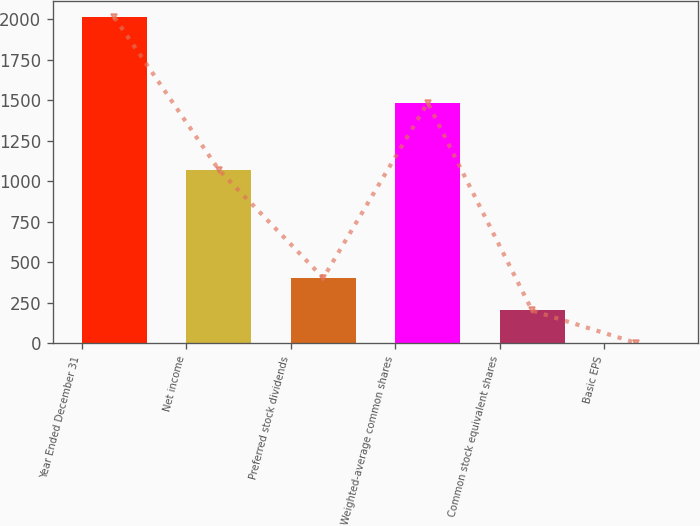<chart> <loc_0><loc_0><loc_500><loc_500><bar_chart><fcel>Year Ended December 31<fcel>Net income<fcel>Preferred stock dividends<fcel>Weighted-average common shares<fcel>Common stock equivalent shares<fcel>Basic EPS<nl><fcel>2013<fcel>1071<fcel>403.22<fcel>1486.22<fcel>202<fcel>0.78<nl></chart> 